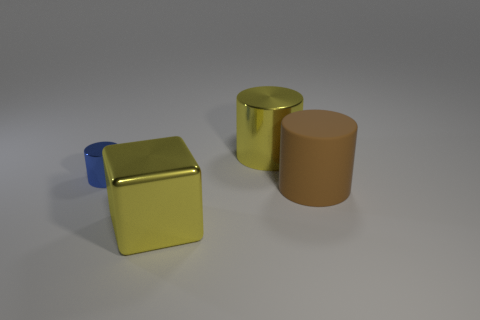What is the size of the blue cylinder?
Provide a succinct answer. Small. Is the number of big shiny cubes to the left of the yellow cylinder greater than the number of tiny purple shiny cylinders?
Give a very brief answer. Yes. Are there any other things that have the same material as the brown cylinder?
Your response must be concise. No. Is the color of the large cylinder behind the small shiny thing the same as the large metal object that is in front of the big brown matte object?
Your response must be concise. Yes. The large yellow object that is to the right of the large yellow object that is in front of the yellow metallic thing that is right of the yellow metal cube is made of what material?
Provide a short and direct response. Metal. Are there more large yellow metal cylinders than big yellow metal things?
Your answer should be compact. No. Is there anything else of the same color as the large metallic block?
Provide a short and direct response. Yes. There is a blue thing that is made of the same material as the large yellow cube; what size is it?
Your answer should be very brief. Small. What is the material of the yellow cube?
Offer a very short reply. Metal. What number of metal things are the same size as the yellow cylinder?
Keep it short and to the point. 1. 